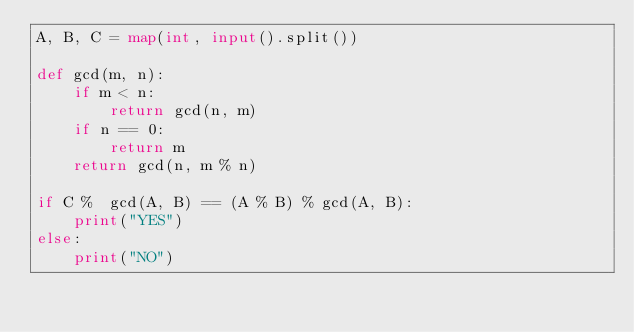<code> <loc_0><loc_0><loc_500><loc_500><_Python_>A, B, C = map(int, input().split())

def gcd(m, n):
    if m < n:
        return gcd(n, m)
    if n == 0:
        return m
    return gcd(n, m % n)

if C %  gcd(A, B) == (A % B) % gcd(A, B):
    print("YES")
else:
    print("NO")</code> 